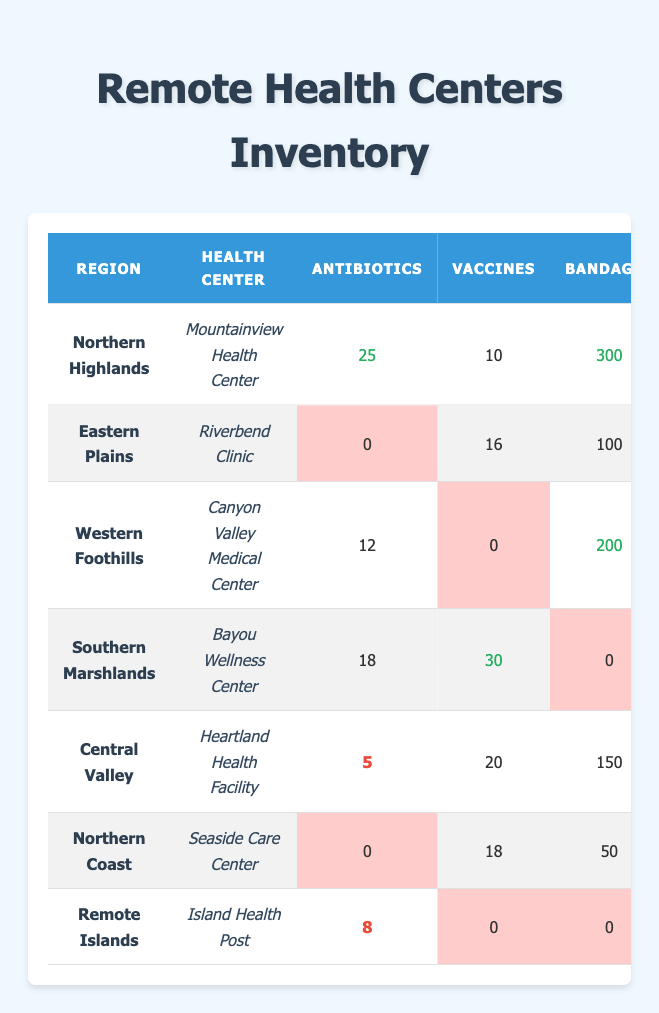What is the stock level of antibiotics at Mountainview Health Center? The table shows that Mountainview Health Center has 25 antibiotics in stock.
Answer: 25 Which health center has the highest stock of bandages? By looking at the table, Mountainview Health Center has 300 bandages, which is more than any other health center.
Answer: Mountainview Health Center How many health centers have no stock of syringes? Checking the table, Riverbend Clinic and Island Health Post both have 0 syringes in stock, which totals to 2 health centers.
Answer: 2 What is the total number of vaccines available at health centers in the Northern Highlands and Southern Marshlands? The Northern Highlands has 10 vaccines at Mountainview Health Center, and the Southern Marshlands has 30 vaccines at Bayou Wellness Center. Adding those gives 10 + 30 = 40.
Answer: 40 Is there any health center in the Eastern Plains region that has sufficient stock of antibiotics? The table shows that Riverbend Clinic has 0 antibiotics, which means it does not have sufficient stock.
Answer: No What is the overall average quantity of pain relievers across all health centers? First, sum the pain relievers across all health centers: (15 + 5 + 8 + 12 + 10 + 7 + 3) = 60. There are 7 health centers, so the average is 60/7 ≈ 8.57.
Answer: 8.57 Which region has the least total number of essential supplies (antibiotics, vaccines, bandages, syringes, and pain relievers) combined? To find the region with the least total supplies, calculate total supplies for each health center: Northern Highlands (25 + 10 + 300 + 50 + 15 = 400), Eastern Plains (0 + 16 + 100 + 0 + 5 = 121), Western Foothills (12 + 0 + 200 + 20 + 8 = 240), Southern Marshlands (18 + 30 + 0 + 40 + 12 = 100), Central Valley (5 + 20 + 150 + 30 + 10 = 215), Northern Coast (0 + 18 + 50 + 25 + 7 = 100), Remote Islands (8 + 0 + 0 + 10 + 3 = 21). The Remote Islands' total is 21, which is the least.
Answer: Remote Islands How many more vaccines are available at the Heartland Health Facility compared to the Island Health Post? Heartland Health Facility has 20 vaccines and Island Health Post has 0. The difference is 20 - 0 = 20.
Answer: 20 Identify which health center has the highest number of syringes available? By scanning the table, Bayou Wellness Center has the highest quantity with 40 syringes.
Answer: Bayou Wellness Center What percentage of health centers have low stock of pain relievers (defined as 5 or fewer)? Health centers with low stock of pain relievers are Riverbend Clinic (5), Canyon Valley Medical Center (8 with at least 8), Seaside Care Center (7), and Island Health Post (3). Riverbend Clinic and Island Health Post fit the criteria. Of the total 7 health centers, 2 have low stock, making it (2/7) * 100 ≈ 28.57%.
Answer: ~28.57% 